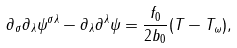<formula> <loc_0><loc_0><loc_500><loc_500>\partial _ { \sigma } \partial _ { \lambda } \psi ^ { \sigma \lambda } - \partial _ { \lambda } \partial ^ { \lambda } \psi = \frac { f _ { 0 } } { 2 b _ { 0 } } ( T - T _ { \omega } ) ,</formula> 